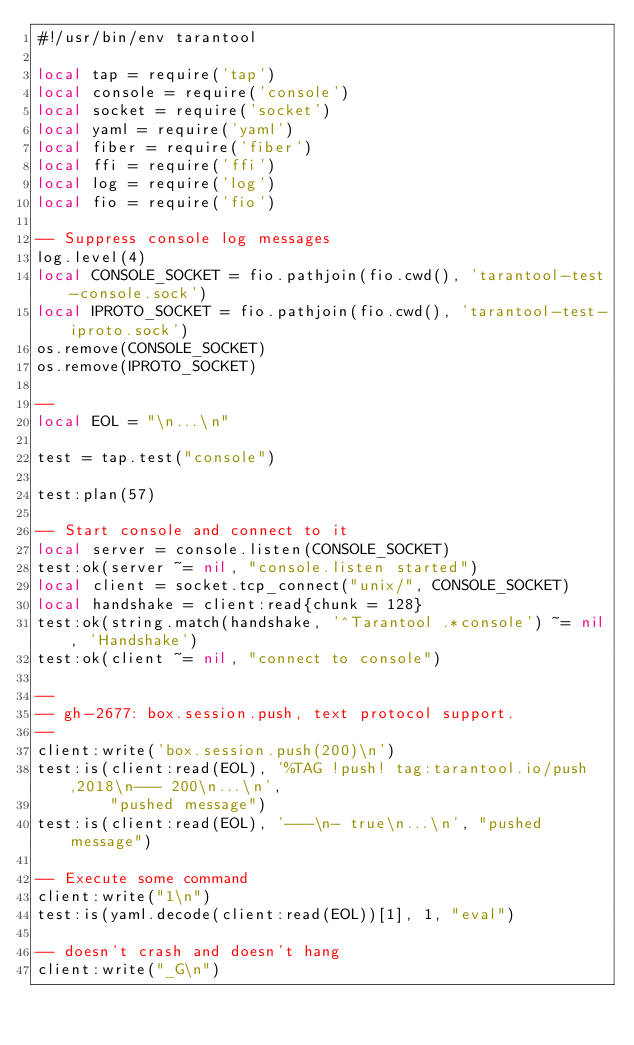<code> <loc_0><loc_0><loc_500><loc_500><_Lua_>#!/usr/bin/env tarantool

local tap = require('tap')
local console = require('console')
local socket = require('socket')
local yaml = require('yaml')
local fiber = require('fiber')
local ffi = require('ffi')
local log = require('log')
local fio = require('fio')

-- Suppress console log messages
log.level(4)
local CONSOLE_SOCKET = fio.pathjoin(fio.cwd(), 'tarantool-test-console.sock')
local IPROTO_SOCKET = fio.pathjoin(fio.cwd(), 'tarantool-test-iproto.sock')
os.remove(CONSOLE_SOCKET)
os.remove(IPROTO_SOCKET)

--
local EOL = "\n...\n"

test = tap.test("console")

test:plan(57)

-- Start console and connect to it
local server = console.listen(CONSOLE_SOCKET)
test:ok(server ~= nil, "console.listen started")
local client = socket.tcp_connect("unix/", CONSOLE_SOCKET)
local handshake = client:read{chunk = 128}
test:ok(string.match(handshake, '^Tarantool .*console') ~= nil, 'Handshake')
test:ok(client ~= nil, "connect to console")

--
-- gh-2677: box.session.push, text protocol support.
--
client:write('box.session.push(200)\n')
test:is(client:read(EOL), '%TAG !push! tag:tarantool.io/push,2018\n--- 200\n...\n',
        "pushed message")
test:is(client:read(EOL), '---\n- true\n...\n', "pushed message")

-- Execute some command
client:write("1\n")
test:is(yaml.decode(client:read(EOL))[1], 1, "eval")

-- doesn't crash and doesn't hang
client:write("_G\n")</code> 